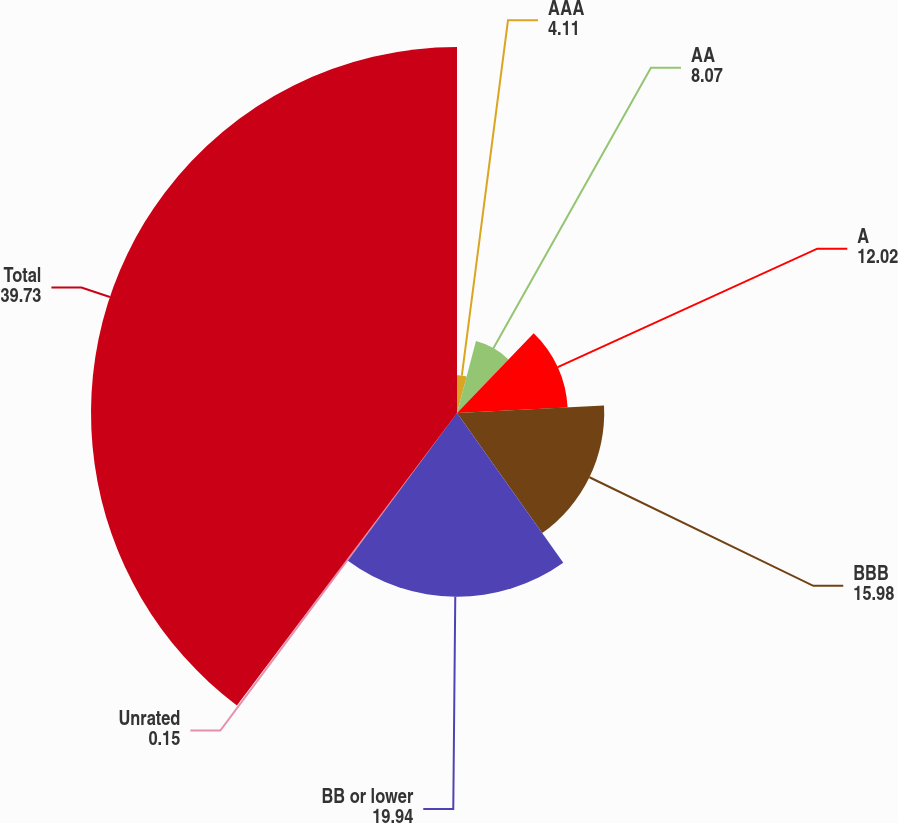Convert chart to OTSL. <chart><loc_0><loc_0><loc_500><loc_500><pie_chart><fcel>AAA<fcel>AA<fcel>A<fcel>BBB<fcel>BB or lower<fcel>Unrated<fcel>Total<nl><fcel>4.11%<fcel>8.07%<fcel>12.02%<fcel>15.98%<fcel>19.94%<fcel>0.15%<fcel>39.73%<nl></chart> 